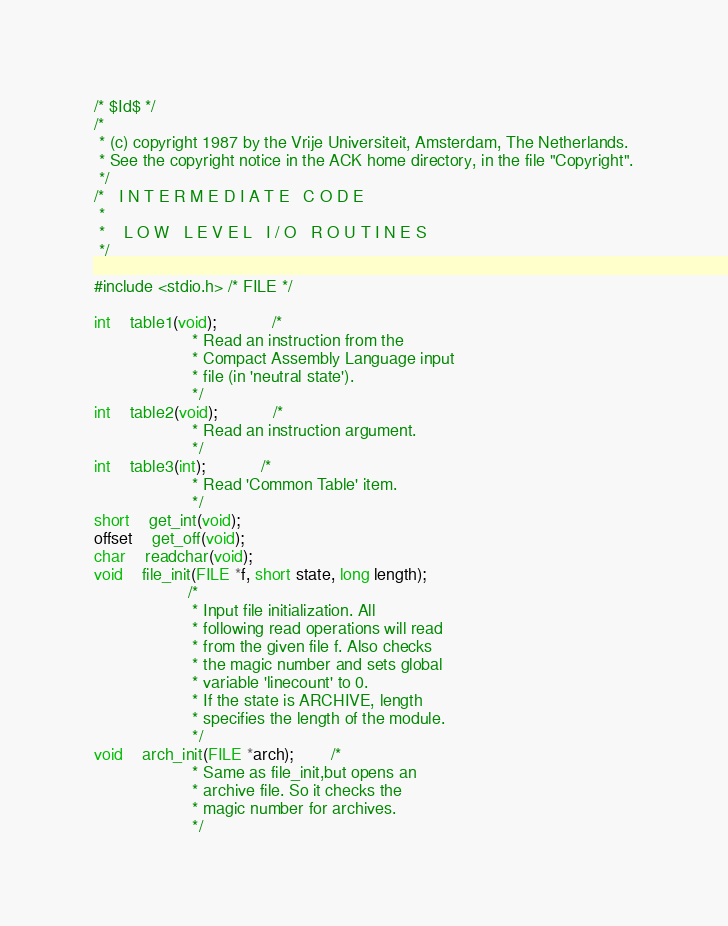Convert code to text. <code><loc_0><loc_0><loc_500><loc_500><_C_>/* $Id$ */
/*
 * (c) copyright 1987 by the Vrije Universiteit, Amsterdam, The Netherlands.
 * See the copyright notice in the ACK home directory, in the file "Copyright".
 */
/*   I N T E R M E D I A T E   C O D E
 *
 *    L O W   L E V E L   I / O   R O U T I N E S
 */

#include <stdio.h> /* FILE */

int	table1(void);			/*
					 * Read an instruction from the
					 * Compact Assembly Language input
					 * file (in 'neutral state').
					 */
int	table2(void);			/*
					 * Read an instruction argument.
					 */
int	table3(int);			/*
					 * Read 'Common Table' item.
					 */
short	get_int(void);
offset	get_off(void);
char	readchar(void);
void	file_init(FILE *f, short state, long length);
					/*
					 * Input file initialization. All
					 * following read operations will read
					 * from the given file f. Also checks
					 * the magic number and sets global
					 * variable 'linecount' to 0.
					 * If the state is ARCHIVE, length
					 * specifies the length of the module.
					 */
void	arch_init(FILE *arch);		/*
					 * Same as file_init,but opens an
					 * archive file. So it checks the
					 * magic number for archives.
					 */
</code> 